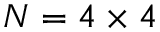<formula> <loc_0><loc_0><loc_500><loc_500>N = 4 \times 4</formula> 